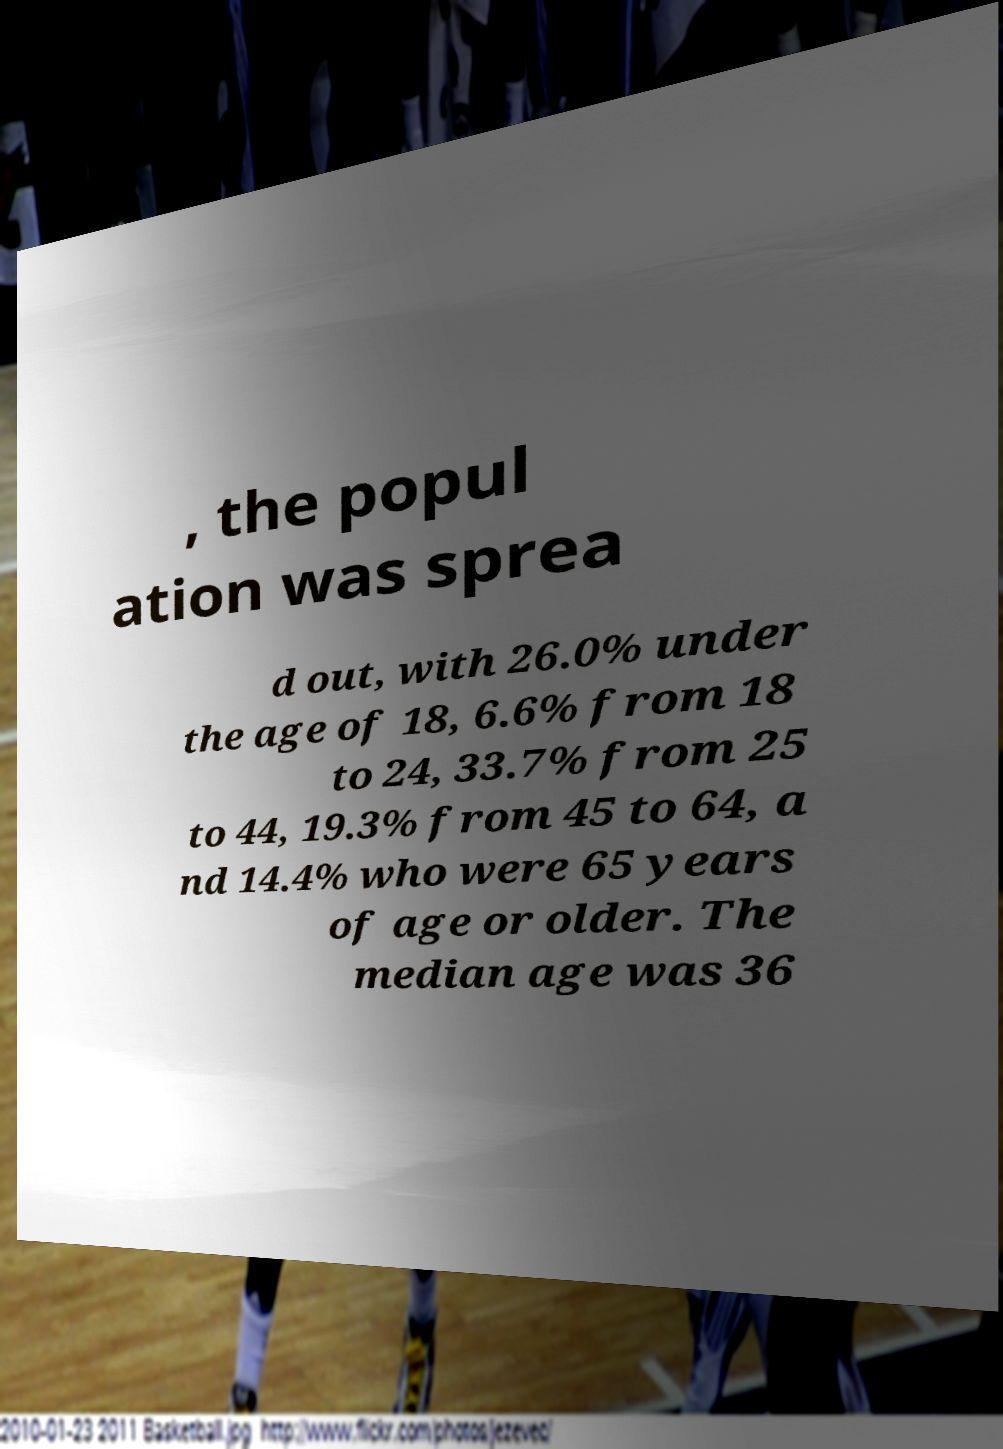Could you extract and type out the text from this image? , the popul ation was sprea d out, with 26.0% under the age of 18, 6.6% from 18 to 24, 33.7% from 25 to 44, 19.3% from 45 to 64, a nd 14.4% who were 65 years of age or older. The median age was 36 